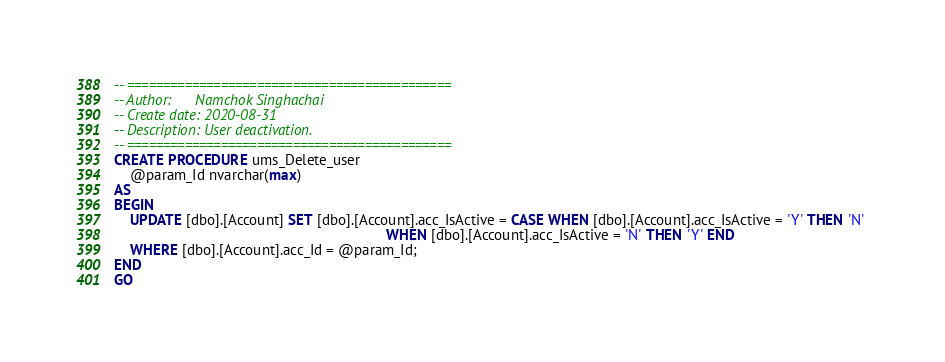Convert code to text. <code><loc_0><loc_0><loc_500><loc_500><_SQL_>-- =============================================
-- Author:		Namchok Singhachai
-- Create date: 2020-08-31
-- Description:	User deactivation.
-- =============================================
CREATE PROCEDURE ums_Delete_user
	@param_Id nvarchar(max)
AS
BEGIN
	UPDATE [dbo].[Account] SET [dbo].[Account].acc_IsActive = CASE WHEN [dbo].[Account].acc_IsActive = 'Y' THEN 'N' 
																	WHEN [dbo].[Account].acc_IsActive = 'N' THEN 'Y' END
	WHERE [dbo].[Account].acc_Id = @param_Id;
END
GO</code> 